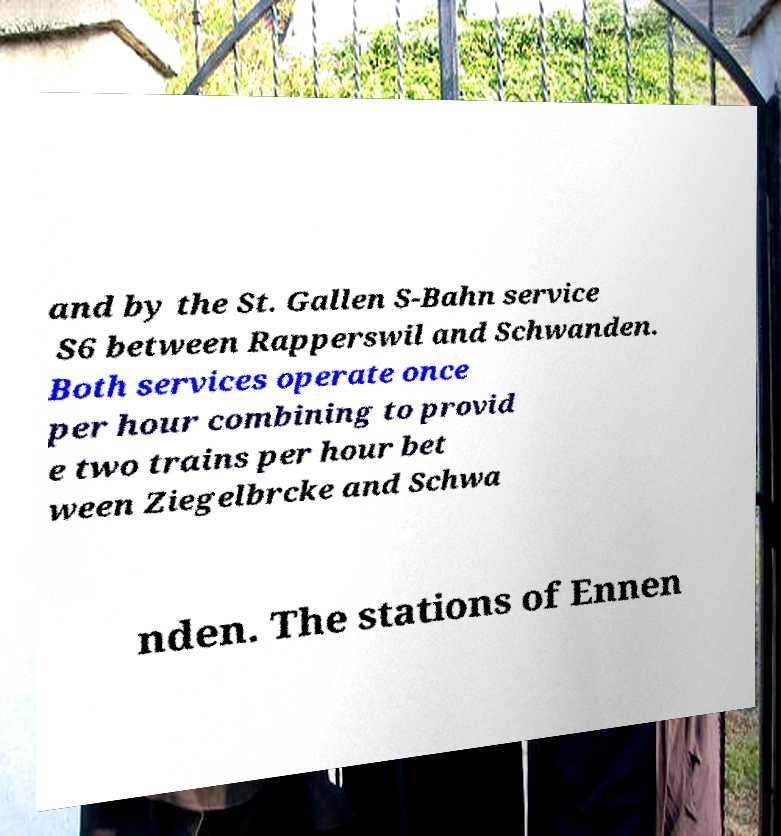For documentation purposes, I need the text within this image transcribed. Could you provide that? and by the St. Gallen S-Bahn service S6 between Rapperswil and Schwanden. Both services operate once per hour combining to provid e two trains per hour bet ween Ziegelbrcke and Schwa nden. The stations of Ennen 